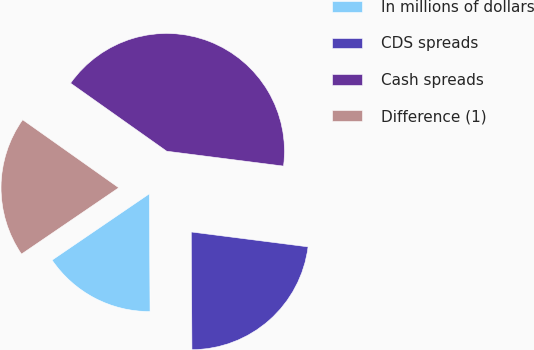Convert chart to OTSL. <chart><loc_0><loc_0><loc_500><loc_500><pie_chart><fcel>In millions of dollars<fcel>CDS spreads<fcel>Cash spreads<fcel>Difference (1)<nl><fcel>15.57%<fcel>22.89%<fcel>42.22%<fcel>19.33%<nl></chart> 